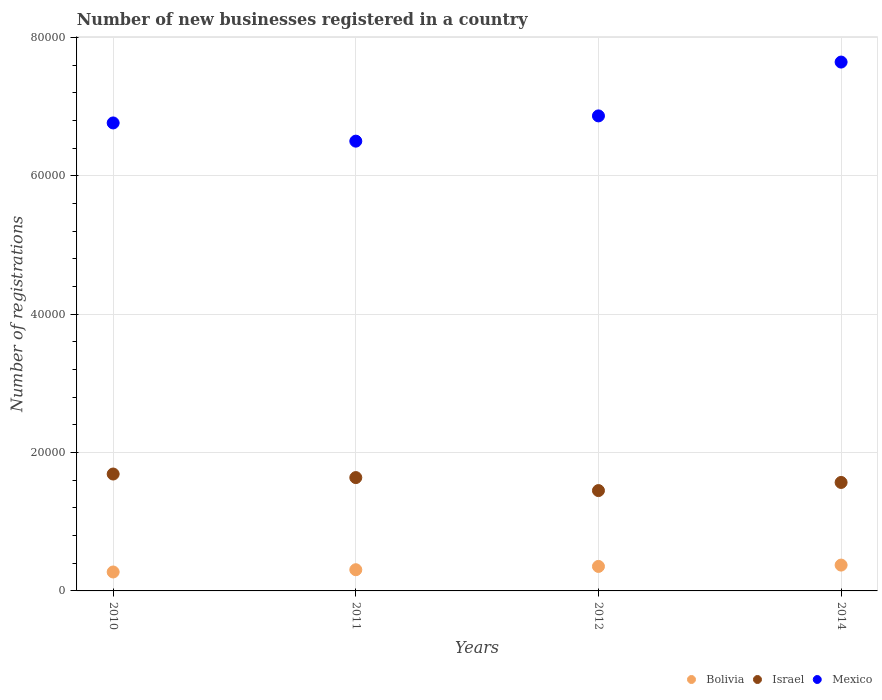What is the number of new businesses registered in Israel in 2012?
Your answer should be compact. 1.45e+04. Across all years, what is the maximum number of new businesses registered in Bolivia?
Give a very brief answer. 3734. Across all years, what is the minimum number of new businesses registered in Mexico?
Ensure brevity in your answer.  6.50e+04. What is the total number of new businesses registered in Mexico in the graph?
Your answer should be compact. 2.78e+05. What is the difference between the number of new businesses registered in Bolivia in 2010 and that in 2014?
Give a very brief answer. -997. What is the difference between the number of new businesses registered in Israel in 2012 and the number of new businesses registered in Mexico in 2010?
Keep it short and to the point. -5.31e+04. What is the average number of new businesses registered in Bolivia per year?
Offer a terse response. 3269.25. In the year 2011, what is the difference between the number of new businesses registered in Israel and number of new businesses registered in Bolivia?
Your response must be concise. 1.33e+04. In how many years, is the number of new businesses registered in Israel greater than 72000?
Offer a very short reply. 0. What is the ratio of the number of new businesses registered in Israel in 2012 to that in 2014?
Provide a succinct answer. 0.93. Is the number of new businesses registered in Bolivia in 2011 less than that in 2014?
Your response must be concise. Yes. Is the difference between the number of new businesses registered in Israel in 2011 and 2012 greater than the difference between the number of new businesses registered in Bolivia in 2011 and 2012?
Keep it short and to the point. Yes. What is the difference between the highest and the second highest number of new businesses registered in Bolivia?
Your response must be concise. 193. What is the difference between the highest and the lowest number of new businesses registered in Israel?
Ensure brevity in your answer.  2394. Is it the case that in every year, the sum of the number of new businesses registered in Israel and number of new businesses registered in Mexico  is greater than the number of new businesses registered in Bolivia?
Ensure brevity in your answer.  Yes. Does the number of new businesses registered in Mexico monotonically increase over the years?
Provide a succinct answer. No. Is the number of new businesses registered in Mexico strictly less than the number of new businesses registered in Bolivia over the years?
Your response must be concise. No. What is the difference between two consecutive major ticks on the Y-axis?
Provide a succinct answer. 2.00e+04. Does the graph contain any zero values?
Make the answer very short. No. Does the graph contain grids?
Provide a short and direct response. Yes. Where does the legend appear in the graph?
Your answer should be compact. Bottom right. How are the legend labels stacked?
Provide a succinct answer. Horizontal. What is the title of the graph?
Keep it short and to the point. Number of new businesses registered in a country. Does "Tajikistan" appear as one of the legend labels in the graph?
Your answer should be compact. No. What is the label or title of the Y-axis?
Give a very brief answer. Number of registrations. What is the Number of registrations of Bolivia in 2010?
Your answer should be very brief. 2737. What is the Number of registrations in Israel in 2010?
Your answer should be very brief. 1.69e+04. What is the Number of registrations of Mexico in 2010?
Your answer should be very brief. 6.76e+04. What is the Number of registrations of Bolivia in 2011?
Offer a very short reply. 3065. What is the Number of registrations of Israel in 2011?
Provide a short and direct response. 1.64e+04. What is the Number of registrations in Mexico in 2011?
Your answer should be compact. 6.50e+04. What is the Number of registrations of Bolivia in 2012?
Provide a short and direct response. 3541. What is the Number of registrations in Israel in 2012?
Offer a very short reply. 1.45e+04. What is the Number of registrations of Mexico in 2012?
Your answer should be compact. 6.87e+04. What is the Number of registrations of Bolivia in 2014?
Your answer should be very brief. 3734. What is the Number of registrations of Israel in 2014?
Make the answer very short. 1.57e+04. What is the Number of registrations of Mexico in 2014?
Keep it short and to the point. 7.64e+04. Across all years, what is the maximum Number of registrations in Bolivia?
Give a very brief answer. 3734. Across all years, what is the maximum Number of registrations of Israel?
Offer a terse response. 1.69e+04. Across all years, what is the maximum Number of registrations of Mexico?
Your answer should be compact. 7.64e+04. Across all years, what is the minimum Number of registrations in Bolivia?
Give a very brief answer. 2737. Across all years, what is the minimum Number of registrations in Israel?
Your answer should be compact. 1.45e+04. Across all years, what is the minimum Number of registrations in Mexico?
Ensure brevity in your answer.  6.50e+04. What is the total Number of registrations in Bolivia in the graph?
Your answer should be compact. 1.31e+04. What is the total Number of registrations in Israel in the graph?
Offer a very short reply. 6.35e+04. What is the total Number of registrations of Mexico in the graph?
Ensure brevity in your answer.  2.78e+05. What is the difference between the Number of registrations in Bolivia in 2010 and that in 2011?
Keep it short and to the point. -328. What is the difference between the Number of registrations in Israel in 2010 and that in 2011?
Ensure brevity in your answer.  515. What is the difference between the Number of registrations of Mexico in 2010 and that in 2011?
Your answer should be very brief. 2632. What is the difference between the Number of registrations of Bolivia in 2010 and that in 2012?
Ensure brevity in your answer.  -804. What is the difference between the Number of registrations of Israel in 2010 and that in 2012?
Ensure brevity in your answer.  2394. What is the difference between the Number of registrations in Mexico in 2010 and that in 2012?
Keep it short and to the point. -1018. What is the difference between the Number of registrations in Bolivia in 2010 and that in 2014?
Offer a very short reply. -997. What is the difference between the Number of registrations of Israel in 2010 and that in 2014?
Provide a short and direct response. 1218. What is the difference between the Number of registrations of Mexico in 2010 and that in 2014?
Your answer should be very brief. -8799. What is the difference between the Number of registrations in Bolivia in 2011 and that in 2012?
Make the answer very short. -476. What is the difference between the Number of registrations in Israel in 2011 and that in 2012?
Provide a short and direct response. 1879. What is the difference between the Number of registrations of Mexico in 2011 and that in 2012?
Keep it short and to the point. -3650. What is the difference between the Number of registrations in Bolivia in 2011 and that in 2014?
Your answer should be very brief. -669. What is the difference between the Number of registrations of Israel in 2011 and that in 2014?
Offer a terse response. 703. What is the difference between the Number of registrations in Mexico in 2011 and that in 2014?
Give a very brief answer. -1.14e+04. What is the difference between the Number of registrations in Bolivia in 2012 and that in 2014?
Give a very brief answer. -193. What is the difference between the Number of registrations in Israel in 2012 and that in 2014?
Your answer should be very brief. -1176. What is the difference between the Number of registrations of Mexico in 2012 and that in 2014?
Your answer should be compact. -7781. What is the difference between the Number of registrations of Bolivia in 2010 and the Number of registrations of Israel in 2011?
Give a very brief answer. -1.36e+04. What is the difference between the Number of registrations of Bolivia in 2010 and the Number of registrations of Mexico in 2011?
Provide a succinct answer. -6.23e+04. What is the difference between the Number of registrations of Israel in 2010 and the Number of registrations of Mexico in 2011?
Your answer should be compact. -4.81e+04. What is the difference between the Number of registrations of Bolivia in 2010 and the Number of registrations of Israel in 2012?
Ensure brevity in your answer.  -1.18e+04. What is the difference between the Number of registrations of Bolivia in 2010 and the Number of registrations of Mexico in 2012?
Offer a very short reply. -6.59e+04. What is the difference between the Number of registrations of Israel in 2010 and the Number of registrations of Mexico in 2012?
Make the answer very short. -5.18e+04. What is the difference between the Number of registrations in Bolivia in 2010 and the Number of registrations in Israel in 2014?
Your answer should be very brief. -1.29e+04. What is the difference between the Number of registrations of Bolivia in 2010 and the Number of registrations of Mexico in 2014?
Provide a short and direct response. -7.37e+04. What is the difference between the Number of registrations of Israel in 2010 and the Number of registrations of Mexico in 2014?
Make the answer very short. -5.95e+04. What is the difference between the Number of registrations of Bolivia in 2011 and the Number of registrations of Israel in 2012?
Ensure brevity in your answer.  -1.14e+04. What is the difference between the Number of registrations of Bolivia in 2011 and the Number of registrations of Mexico in 2012?
Provide a short and direct response. -6.56e+04. What is the difference between the Number of registrations in Israel in 2011 and the Number of registrations in Mexico in 2012?
Your response must be concise. -5.23e+04. What is the difference between the Number of registrations of Bolivia in 2011 and the Number of registrations of Israel in 2014?
Make the answer very short. -1.26e+04. What is the difference between the Number of registrations in Bolivia in 2011 and the Number of registrations in Mexico in 2014?
Make the answer very short. -7.34e+04. What is the difference between the Number of registrations in Israel in 2011 and the Number of registrations in Mexico in 2014?
Your response must be concise. -6.01e+04. What is the difference between the Number of registrations of Bolivia in 2012 and the Number of registrations of Israel in 2014?
Offer a very short reply. -1.21e+04. What is the difference between the Number of registrations of Bolivia in 2012 and the Number of registrations of Mexico in 2014?
Offer a very short reply. -7.29e+04. What is the difference between the Number of registrations in Israel in 2012 and the Number of registrations in Mexico in 2014?
Offer a terse response. -6.19e+04. What is the average Number of registrations in Bolivia per year?
Make the answer very short. 3269.25. What is the average Number of registrations in Israel per year?
Give a very brief answer. 1.59e+04. What is the average Number of registrations of Mexico per year?
Provide a succinct answer. 6.94e+04. In the year 2010, what is the difference between the Number of registrations in Bolivia and Number of registrations in Israel?
Ensure brevity in your answer.  -1.42e+04. In the year 2010, what is the difference between the Number of registrations of Bolivia and Number of registrations of Mexico?
Your answer should be very brief. -6.49e+04. In the year 2010, what is the difference between the Number of registrations of Israel and Number of registrations of Mexico?
Your response must be concise. -5.08e+04. In the year 2011, what is the difference between the Number of registrations in Bolivia and Number of registrations in Israel?
Provide a succinct answer. -1.33e+04. In the year 2011, what is the difference between the Number of registrations in Bolivia and Number of registrations in Mexico?
Keep it short and to the point. -6.20e+04. In the year 2011, what is the difference between the Number of registrations of Israel and Number of registrations of Mexico?
Provide a short and direct response. -4.86e+04. In the year 2012, what is the difference between the Number of registrations of Bolivia and Number of registrations of Israel?
Ensure brevity in your answer.  -1.10e+04. In the year 2012, what is the difference between the Number of registrations in Bolivia and Number of registrations in Mexico?
Your answer should be compact. -6.51e+04. In the year 2012, what is the difference between the Number of registrations in Israel and Number of registrations in Mexico?
Your answer should be compact. -5.42e+04. In the year 2014, what is the difference between the Number of registrations of Bolivia and Number of registrations of Israel?
Offer a terse response. -1.19e+04. In the year 2014, what is the difference between the Number of registrations in Bolivia and Number of registrations in Mexico?
Offer a very short reply. -7.27e+04. In the year 2014, what is the difference between the Number of registrations of Israel and Number of registrations of Mexico?
Provide a short and direct response. -6.08e+04. What is the ratio of the Number of registrations in Bolivia in 2010 to that in 2011?
Ensure brevity in your answer.  0.89. What is the ratio of the Number of registrations in Israel in 2010 to that in 2011?
Your answer should be compact. 1.03. What is the ratio of the Number of registrations in Mexico in 2010 to that in 2011?
Your answer should be very brief. 1.04. What is the ratio of the Number of registrations of Bolivia in 2010 to that in 2012?
Your answer should be compact. 0.77. What is the ratio of the Number of registrations in Israel in 2010 to that in 2012?
Offer a terse response. 1.17. What is the ratio of the Number of registrations in Mexico in 2010 to that in 2012?
Keep it short and to the point. 0.99. What is the ratio of the Number of registrations of Bolivia in 2010 to that in 2014?
Keep it short and to the point. 0.73. What is the ratio of the Number of registrations in Israel in 2010 to that in 2014?
Keep it short and to the point. 1.08. What is the ratio of the Number of registrations of Mexico in 2010 to that in 2014?
Ensure brevity in your answer.  0.88. What is the ratio of the Number of registrations in Bolivia in 2011 to that in 2012?
Your answer should be very brief. 0.87. What is the ratio of the Number of registrations of Israel in 2011 to that in 2012?
Your answer should be compact. 1.13. What is the ratio of the Number of registrations of Mexico in 2011 to that in 2012?
Offer a very short reply. 0.95. What is the ratio of the Number of registrations of Bolivia in 2011 to that in 2014?
Provide a succinct answer. 0.82. What is the ratio of the Number of registrations of Israel in 2011 to that in 2014?
Provide a short and direct response. 1.04. What is the ratio of the Number of registrations in Mexico in 2011 to that in 2014?
Your answer should be very brief. 0.85. What is the ratio of the Number of registrations in Bolivia in 2012 to that in 2014?
Provide a short and direct response. 0.95. What is the ratio of the Number of registrations in Israel in 2012 to that in 2014?
Your answer should be compact. 0.93. What is the ratio of the Number of registrations in Mexico in 2012 to that in 2014?
Offer a terse response. 0.9. What is the difference between the highest and the second highest Number of registrations of Bolivia?
Provide a short and direct response. 193. What is the difference between the highest and the second highest Number of registrations of Israel?
Your answer should be very brief. 515. What is the difference between the highest and the second highest Number of registrations in Mexico?
Make the answer very short. 7781. What is the difference between the highest and the lowest Number of registrations of Bolivia?
Provide a short and direct response. 997. What is the difference between the highest and the lowest Number of registrations of Israel?
Keep it short and to the point. 2394. What is the difference between the highest and the lowest Number of registrations of Mexico?
Ensure brevity in your answer.  1.14e+04. 